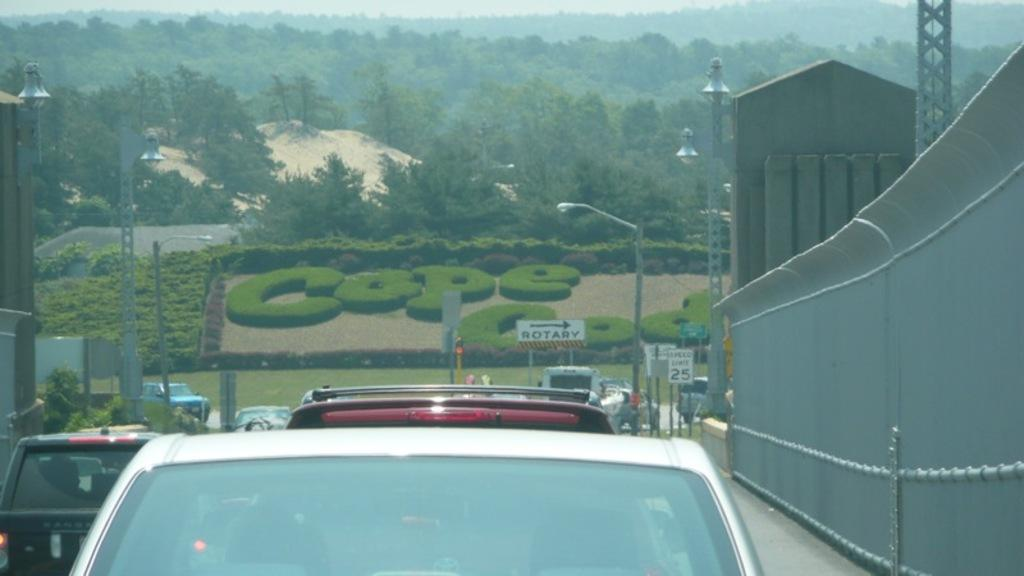What can be seen on the road in the image? There are vehicles on the road in the image. What is located on the side of the road? There is a railing on the side of the road. What structures are visible in the image? Light poles are visible in the image. What type of natural features can be seen in the image? Trees and mountains are visible in the image. What part of the environment is visible in the image? The sky is visible in the image. What type of calculator is being used by the family in the image? There is no calculator or family present in the image; it features vehicles on the road, a railing, light poles, trees, mountains, and the sky. What is the reason for the vehicles being on the road in the image? The image does not provide information about the reason for the vehicles being on the road; it simply shows them in motion. 